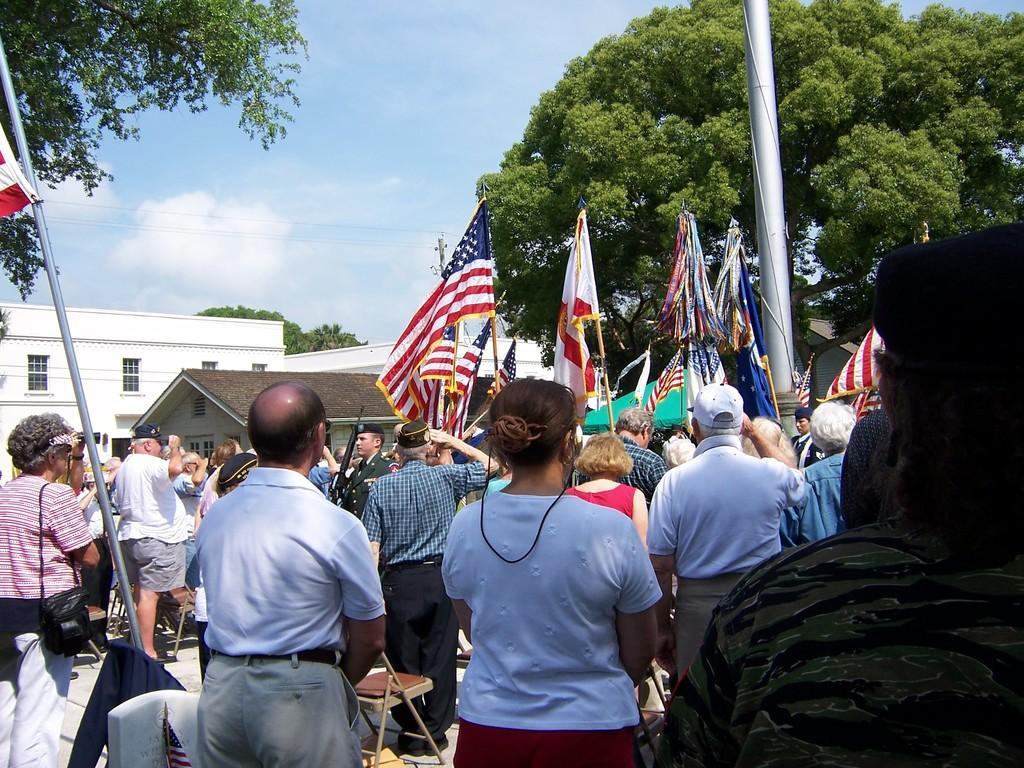Describe this image in one or two sentences. In the image there are many flags and around the flags there is a crowd and most of them are saluting to the flags, in the background there is a huge tree and around the tree there are houses. 